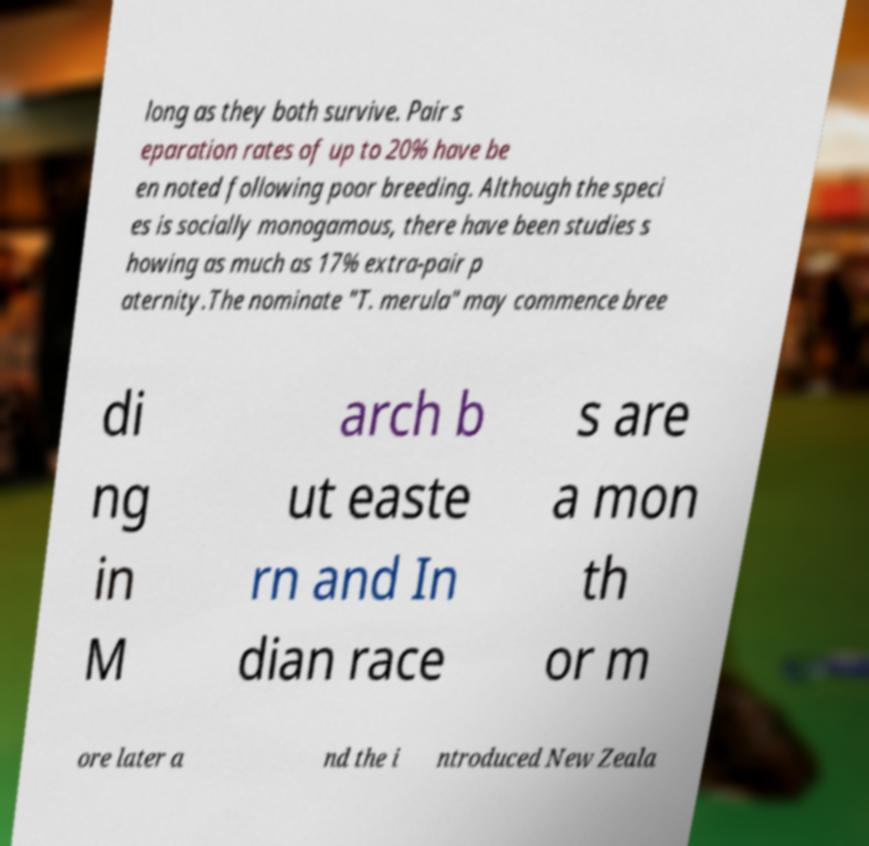For documentation purposes, I need the text within this image transcribed. Could you provide that? long as they both survive. Pair s eparation rates of up to 20% have be en noted following poor breeding. Although the speci es is socially monogamous, there have been studies s howing as much as 17% extra-pair p aternity.The nominate "T. merula" may commence bree di ng in M arch b ut easte rn and In dian race s are a mon th or m ore later a nd the i ntroduced New Zeala 